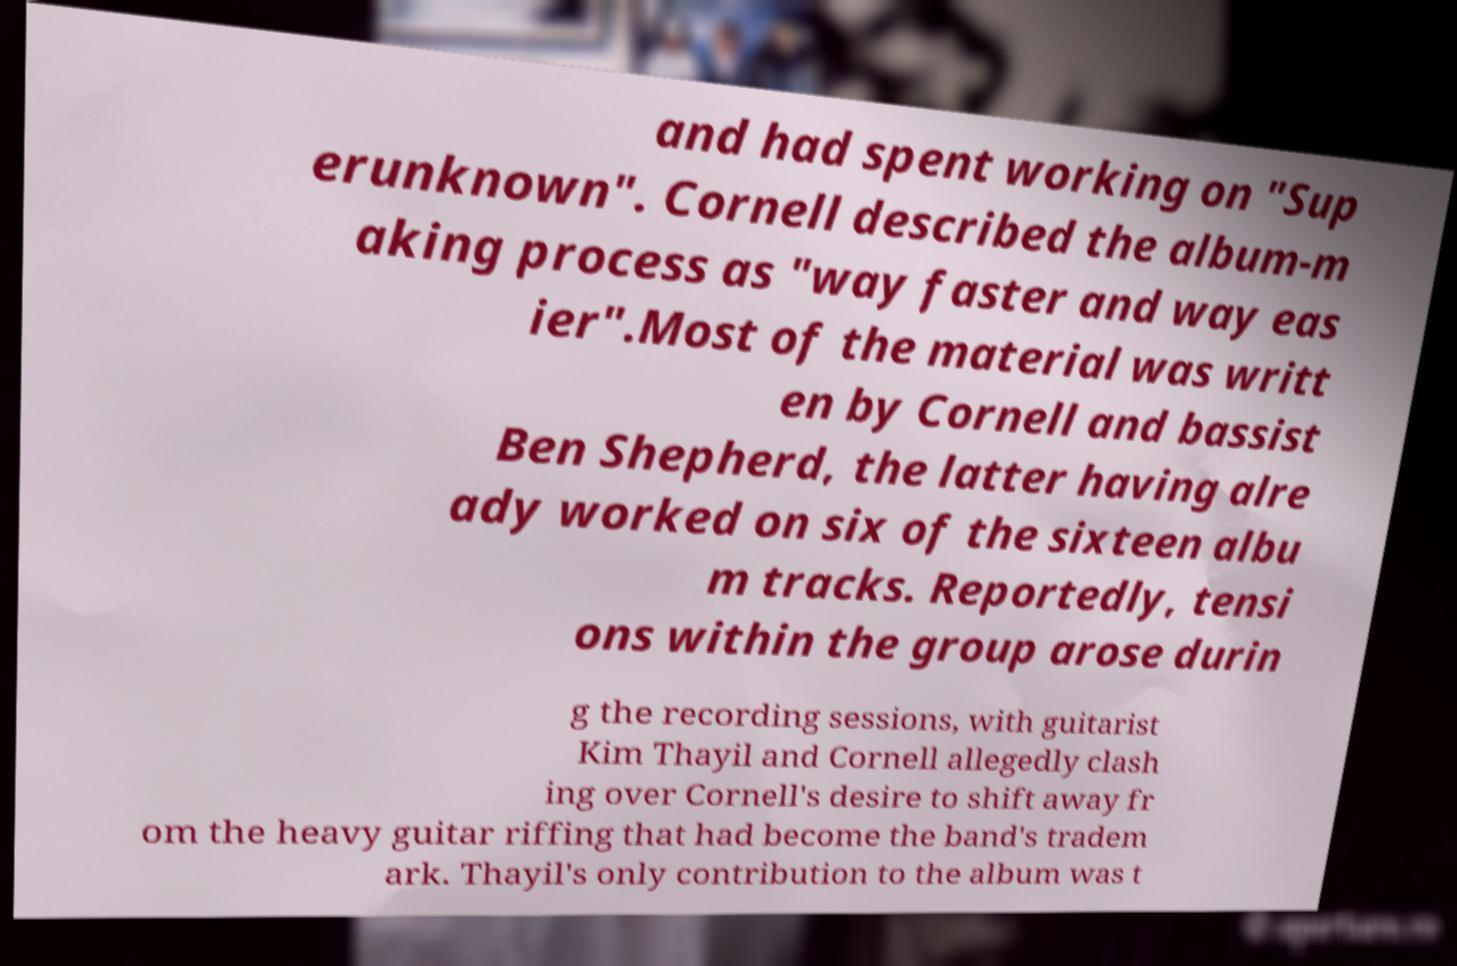There's text embedded in this image that I need extracted. Can you transcribe it verbatim? and had spent working on "Sup erunknown". Cornell described the album-m aking process as "way faster and way eas ier".Most of the material was writt en by Cornell and bassist Ben Shepherd, the latter having alre ady worked on six of the sixteen albu m tracks. Reportedly, tensi ons within the group arose durin g the recording sessions, with guitarist Kim Thayil and Cornell allegedly clash ing over Cornell's desire to shift away fr om the heavy guitar riffing that had become the band's tradem ark. Thayil's only contribution to the album was t 